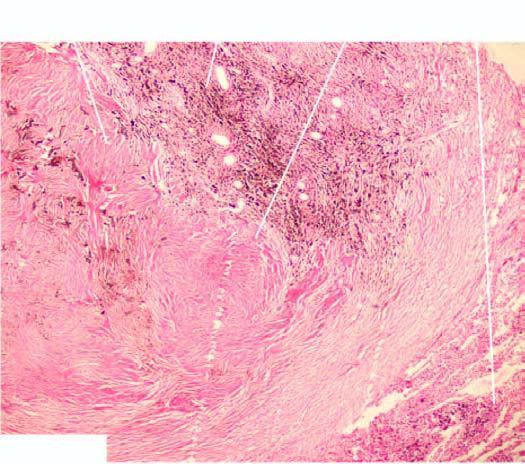what are seen surrounding respiratory bronchioles?
Answer the question using a single word or phrase. Coal macules composed of aggregates of dust-laden macrophages and collagens 